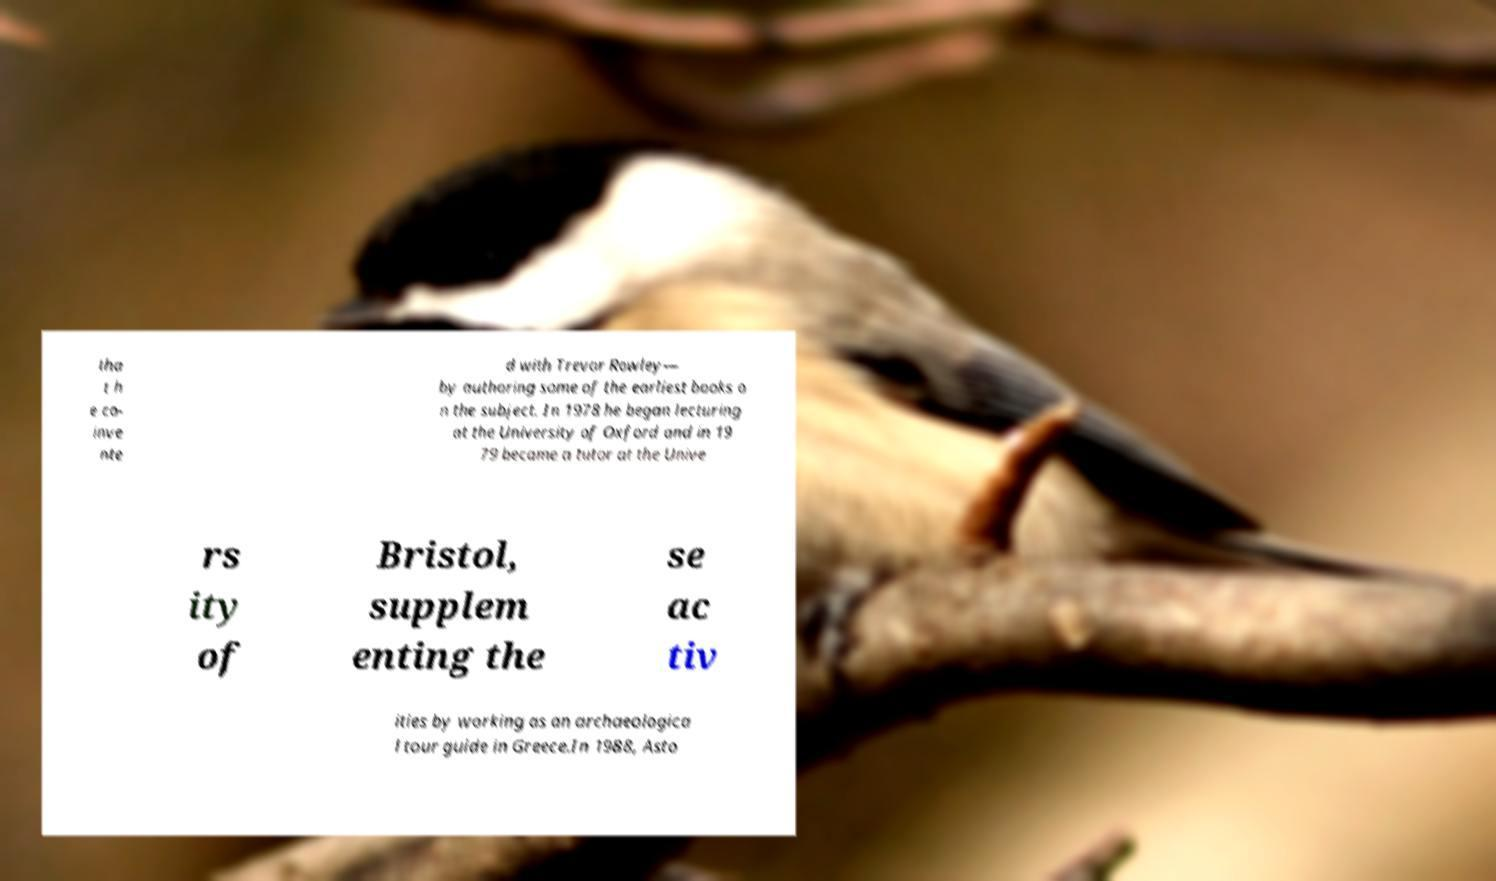There's text embedded in this image that I need extracted. Can you transcribe it verbatim? tha t h e co- inve nte d with Trevor Rowley— by authoring some of the earliest books o n the subject. In 1978 he began lecturing at the University of Oxford and in 19 79 became a tutor at the Unive rs ity of Bristol, supplem enting the se ac tiv ities by working as an archaeologica l tour guide in Greece.In 1988, Asto 